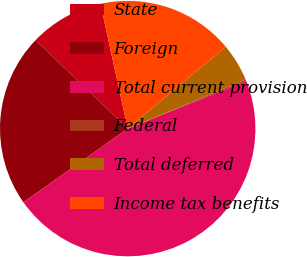Convert chart. <chart><loc_0><loc_0><loc_500><loc_500><pie_chart><fcel>State<fcel>Foreign<fcel>Total current provision<fcel>Federal<fcel>Total deferred<fcel>Income tax benefits<nl><fcel>9.42%<fcel>21.95%<fcel>46.28%<fcel>0.2%<fcel>4.81%<fcel>17.34%<nl></chart> 